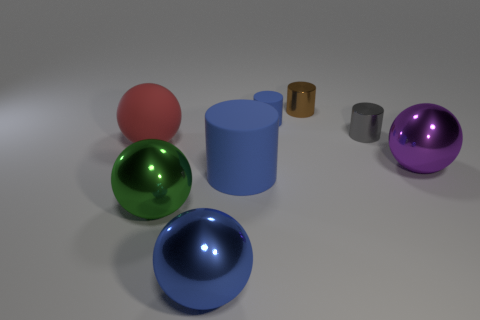What size is the ball that is the same color as the small matte object?
Provide a succinct answer. Large. What material is the large cylinder that is the same color as the small rubber object?
Your answer should be very brief. Rubber. The other rubber sphere that is the same size as the purple sphere is what color?
Your answer should be compact. Red. Is the size of the gray cylinder the same as the blue ball?
Keep it short and to the point. No. There is a ball that is both behind the big blue rubber cylinder and on the left side of the big purple sphere; how big is it?
Keep it short and to the point. Large. What number of metallic things are either tiny cyan cylinders or tiny blue objects?
Ensure brevity in your answer.  0. Is the number of large purple metal things that are in front of the purple shiny object greater than the number of small red things?
Provide a short and direct response. No. There is a ball on the right side of the gray metal cylinder; what is it made of?
Make the answer very short. Metal. How many large blue objects have the same material as the red object?
Keep it short and to the point. 1. There is a metal thing that is left of the gray metal object and to the right of the big blue rubber cylinder; what is its shape?
Your response must be concise. Cylinder. 